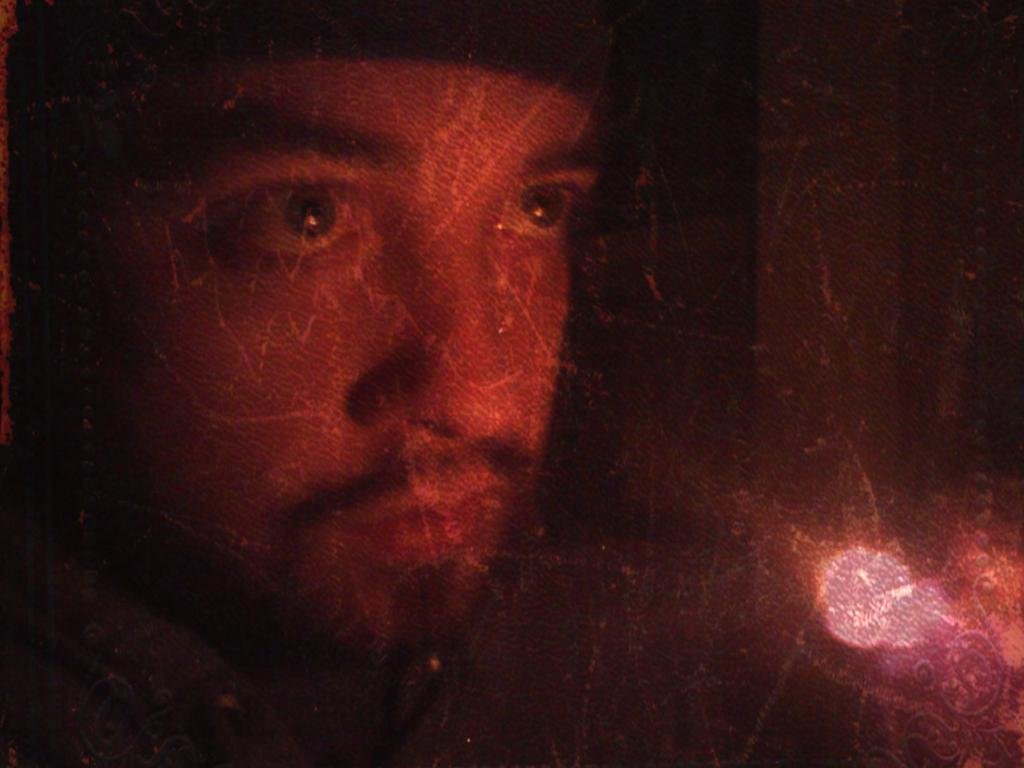Who is the main subject in the image? There is a boy in the image. Where is the boy located in the image? The boy is on the left side of the image. What can be seen on the right side of the image? There is a light on the right side of the image. What type of hospital is visible in the image? There is no hospital present in the image. How many dogs are interacting with the boy in the image? There are no dogs present in the image. 